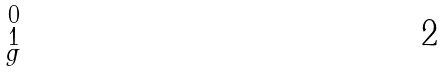<formula> <loc_0><loc_0><loc_500><loc_500>\begin{smallmatrix} 0 \\ 1 \\ g \end{smallmatrix}</formula> 